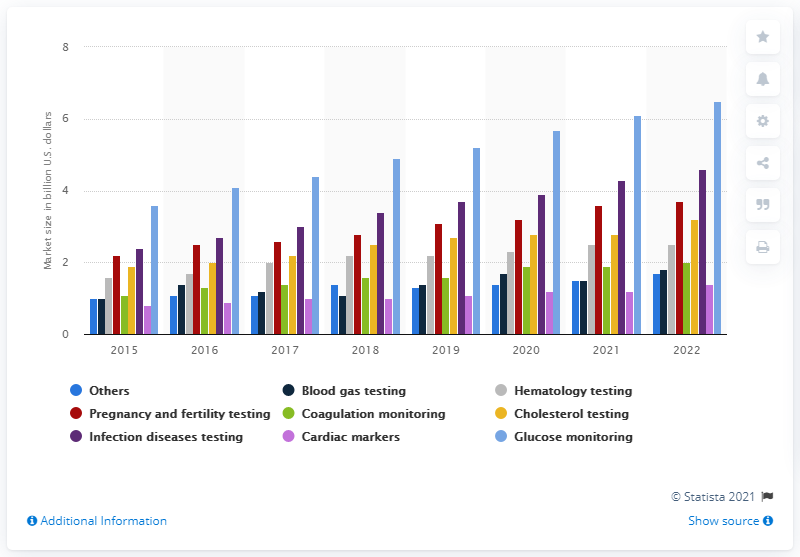Highlight a few significant elements in this photo. In 2015, the market for blood gas testing was estimated to be approximately $0.9 billion. According to estimates, the market size for blood gas testing is expected to reach 1.8 by 2022. 